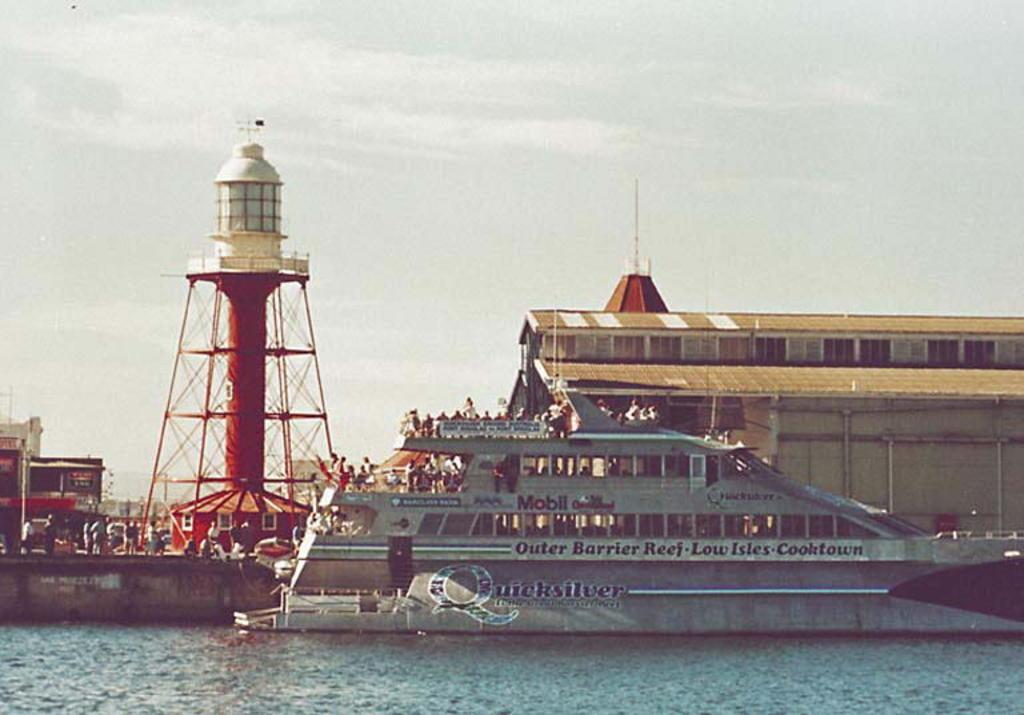<image>
Create a compact narrative representing the image presented. Ship in the waters with the name Quicksilver on it. 